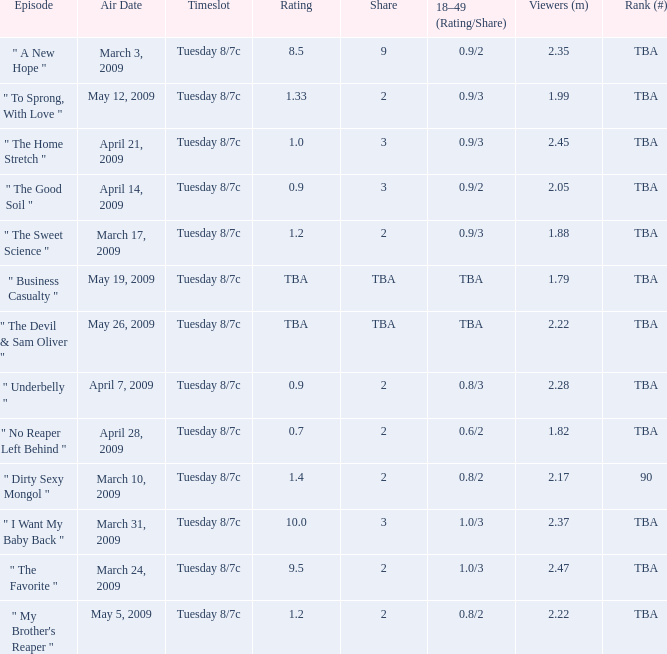What is the rank for the show aired on May 19, 2009? TBA. 